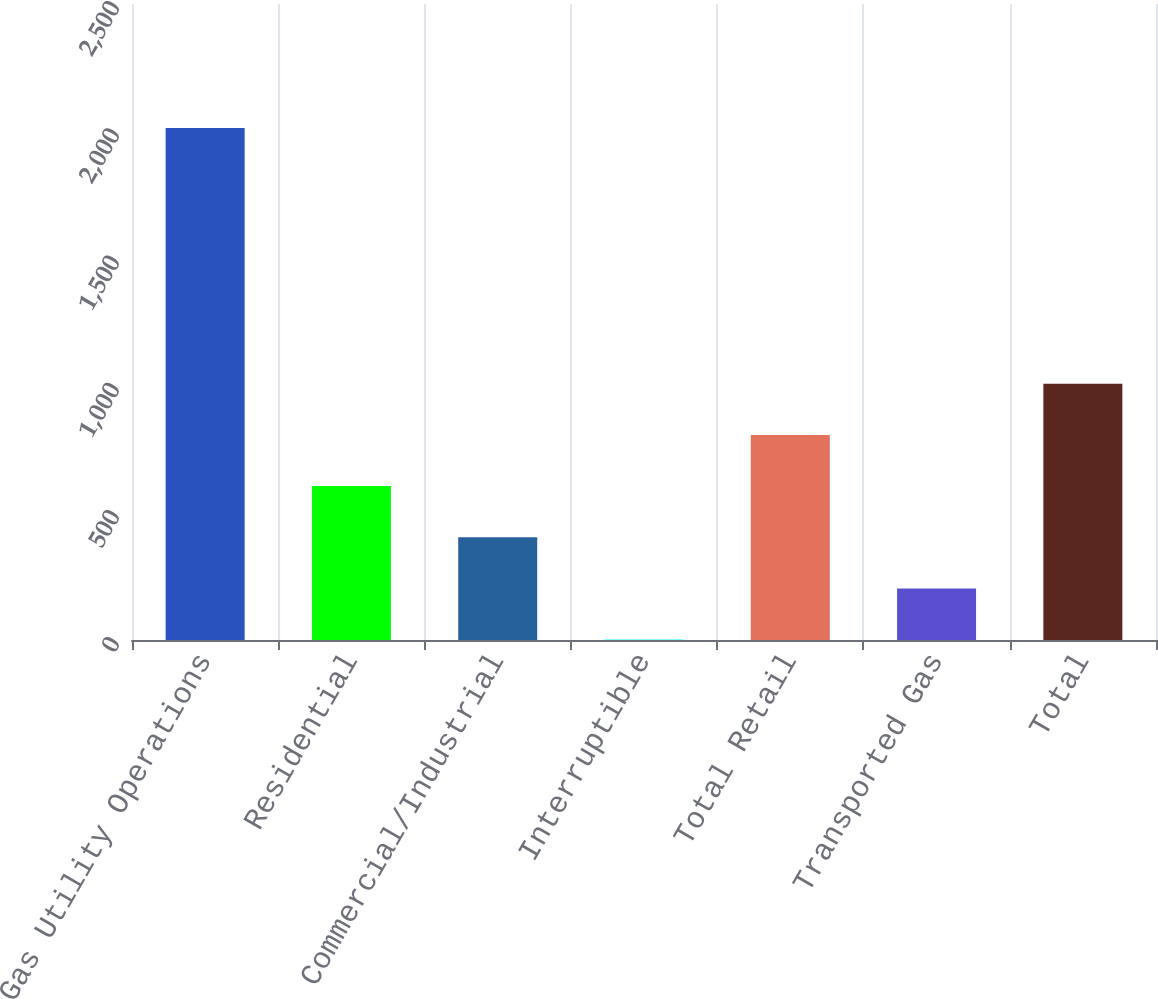Convert chart to OTSL. <chart><loc_0><loc_0><loc_500><loc_500><bar_chart><fcel>Gas Utility Operations<fcel>Residential<fcel>Commercial/Industrial<fcel>Interruptible<fcel>Total Retail<fcel>Transported Gas<fcel>Total<nl><fcel>2013<fcel>605.16<fcel>404.04<fcel>1.8<fcel>806.28<fcel>202.92<fcel>1007.4<nl></chart> 